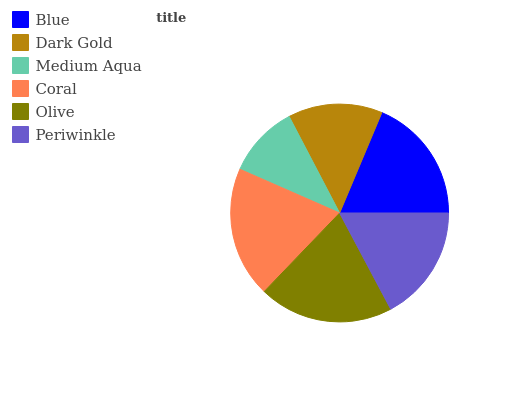Is Medium Aqua the minimum?
Answer yes or no. Yes. Is Olive the maximum?
Answer yes or no. Yes. Is Dark Gold the minimum?
Answer yes or no. No. Is Dark Gold the maximum?
Answer yes or no. No. Is Blue greater than Dark Gold?
Answer yes or no. Yes. Is Dark Gold less than Blue?
Answer yes or no. Yes. Is Dark Gold greater than Blue?
Answer yes or no. No. Is Blue less than Dark Gold?
Answer yes or no. No. Is Blue the high median?
Answer yes or no. Yes. Is Periwinkle the low median?
Answer yes or no. Yes. Is Medium Aqua the high median?
Answer yes or no. No. Is Olive the low median?
Answer yes or no. No. 